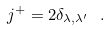Convert formula to latex. <formula><loc_0><loc_0><loc_500><loc_500>j ^ { + } = 2 \delta _ { \lambda , \lambda ^ { \prime } } \ .</formula> 